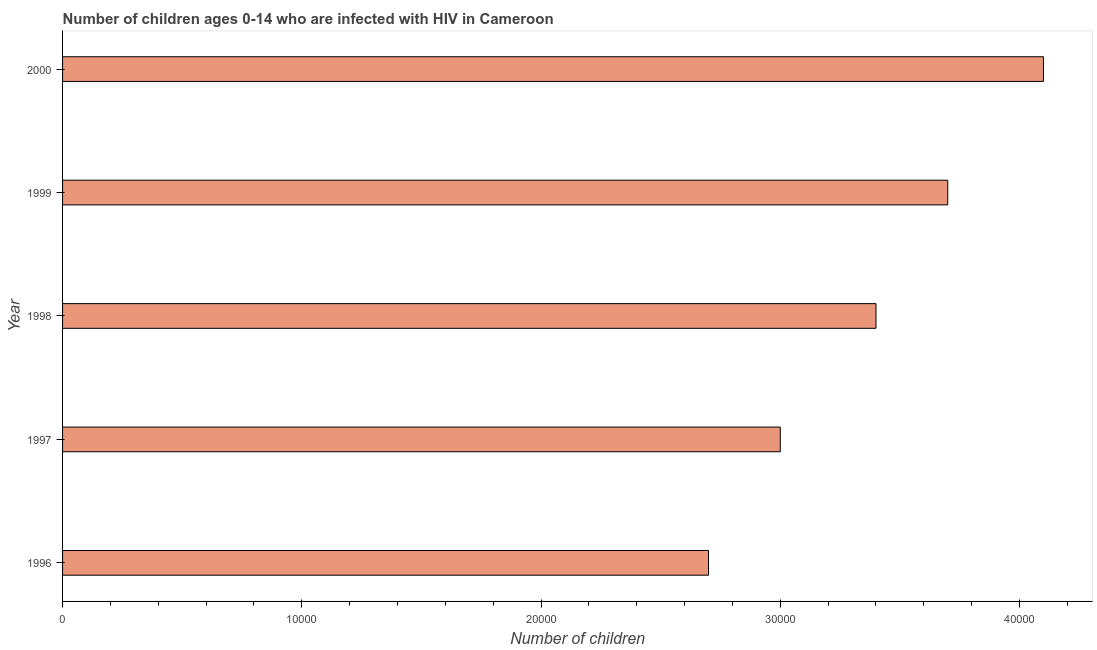Does the graph contain any zero values?
Keep it short and to the point. No. What is the title of the graph?
Give a very brief answer. Number of children ages 0-14 who are infected with HIV in Cameroon. What is the label or title of the X-axis?
Your response must be concise. Number of children. What is the label or title of the Y-axis?
Offer a terse response. Year. Across all years, what is the maximum number of children living with hiv?
Keep it short and to the point. 4.10e+04. Across all years, what is the minimum number of children living with hiv?
Ensure brevity in your answer.  2.70e+04. What is the sum of the number of children living with hiv?
Make the answer very short. 1.69e+05. What is the difference between the number of children living with hiv in 1996 and 2000?
Offer a very short reply. -1.40e+04. What is the average number of children living with hiv per year?
Your answer should be compact. 3.38e+04. What is the median number of children living with hiv?
Ensure brevity in your answer.  3.40e+04. What is the ratio of the number of children living with hiv in 1996 to that in 2000?
Keep it short and to the point. 0.66. Is the number of children living with hiv in 1998 less than that in 2000?
Offer a terse response. Yes. What is the difference between the highest and the second highest number of children living with hiv?
Provide a succinct answer. 4000. Is the sum of the number of children living with hiv in 1999 and 2000 greater than the maximum number of children living with hiv across all years?
Your answer should be compact. Yes. What is the difference between the highest and the lowest number of children living with hiv?
Provide a succinct answer. 1.40e+04. How many bars are there?
Make the answer very short. 5. What is the Number of children of 1996?
Keep it short and to the point. 2.70e+04. What is the Number of children in 1997?
Provide a short and direct response. 3.00e+04. What is the Number of children in 1998?
Ensure brevity in your answer.  3.40e+04. What is the Number of children of 1999?
Provide a short and direct response. 3.70e+04. What is the Number of children in 2000?
Offer a terse response. 4.10e+04. What is the difference between the Number of children in 1996 and 1997?
Make the answer very short. -3000. What is the difference between the Number of children in 1996 and 1998?
Your response must be concise. -7000. What is the difference between the Number of children in 1996 and 2000?
Ensure brevity in your answer.  -1.40e+04. What is the difference between the Number of children in 1997 and 1998?
Your response must be concise. -4000. What is the difference between the Number of children in 1997 and 1999?
Offer a very short reply. -7000. What is the difference between the Number of children in 1997 and 2000?
Your answer should be compact. -1.10e+04. What is the difference between the Number of children in 1998 and 1999?
Offer a terse response. -3000. What is the difference between the Number of children in 1998 and 2000?
Offer a terse response. -7000. What is the difference between the Number of children in 1999 and 2000?
Offer a terse response. -4000. What is the ratio of the Number of children in 1996 to that in 1998?
Offer a terse response. 0.79. What is the ratio of the Number of children in 1996 to that in 1999?
Provide a short and direct response. 0.73. What is the ratio of the Number of children in 1996 to that in 2000?
Your answer should be compact. 0.66. What is the ratio of the Number of children in 1997 to that in 1998?
Give a very brief answer. 0.88. What is the ratio of the Number of children in 1997 to that in 1999?
Give a very brief answer. 0.81. What is the ratio of the Number of children in 1997 to that in 2000?
Offer a terse response. 0.73. What is the ratio of the Number of children in 1998 to that in 1999?
Provide a succinct answer. 0.92. What is the ratio of the Number of children in 1998 to that in 2000?
Give a very brief answer. 0.83. What is the ratio of the Number of children in 1999 to that in 2000?
Provide a short and direct response. 0.9. 